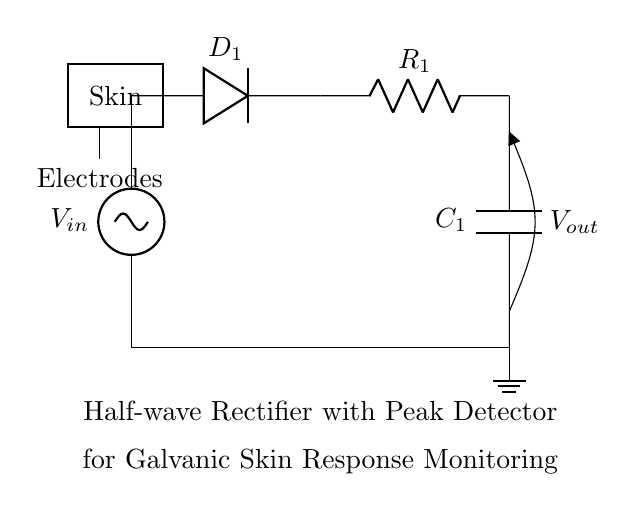What type of rectifier is represented in this circuit? The circuit shows a half-wave rectifier, which only allows one half of the AC signal to pass through while blocking the other half. This is indicated by the single diode which permits current flow in one direction.
Answer: half-wave rectifier What component is used to store charge in this circuit? The component responsible for storing charge is the capacitor, which smooths the output voltage by holding charge and releasing it when the input voltage drops. You can identify the capacitor by its symbol and labeling as C1 in the circuit.
Answer: capacitor What is the function of the diode in this circuit? The diode's function is to allow current to flow during the positive half-cycle of the input AC signal and block it during the negative half-cycle, thus converting AC to DC. This unidirectional behavior is essential for rectification.
Answer: allow current flow in one direction What is the purpose of the resistor in this circuit? The resistor is used to limit the current flowing into the capacitor and to determine the discharge time of the capacitor, influencing the responsiveness of the peak detector to changes in the input voltage over time.
Answer: limit current and set discharge time How does the galvanic skin response relate to this rectification process? The galvanic skin response (GSR) reflects changes in skin conductance due to emotional arousal, which can be monitored using the output voltage from the peak detector of this rectifier circuit as it effectively tracks these rapid changes in skin impedance.
Answer: monitors changes in skin conductance What would happen if the diode were removed from the circuit? If the diode were removed, the AC signal would pass through in both directions, resulting in no rectification and producing a fluctuating output voltage that would not effectively reflect the galvanic skin response.
Answer: no rectification; AC signal passes unaltered 